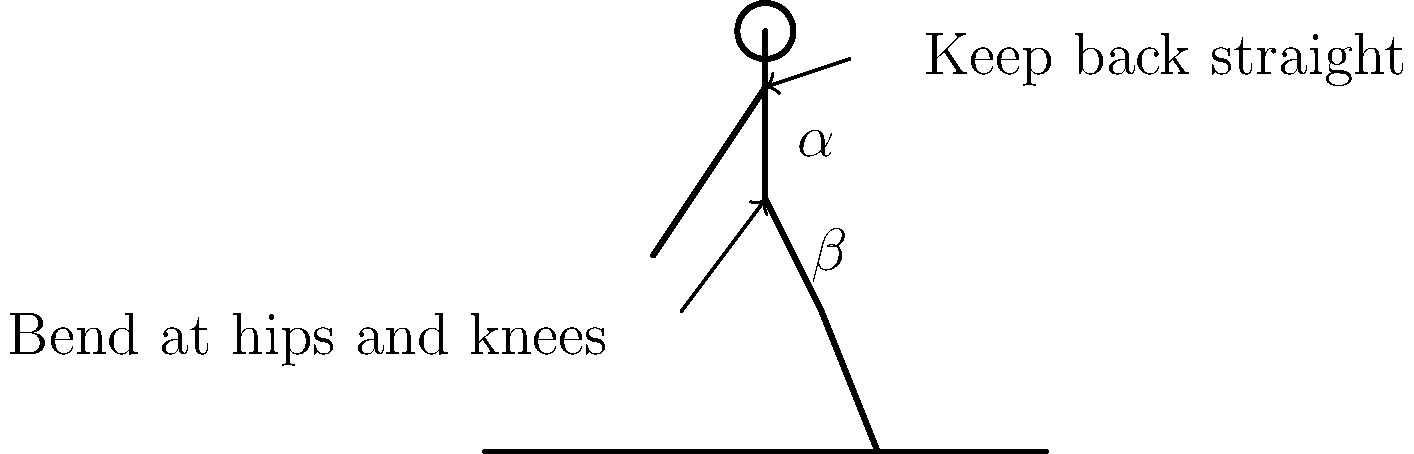When bending to plant seeds in a field, which of the following practices is most important for maintaining proper biomechanics and reducing the risk of back injury?

A) Bending primarily at the waist
B) Keeping the back straight and bending at the hips and knees
C) Twisting the upper body while bending
D) Reaching as far as possible to plant seeds To understand the correct biomechanics for bending to plant seeds, let's break down the proper technique:

1. Posture: The most crucial aspect is maintaining a straight back. This helps distribute the load evenly across the spine, reducing the risk of injury.

2. Bending points: Instead of bending primarily at the waist (which puts excessive strain on the lower back), the proper technique involves:
   a) Bending at the hips (hip flexion, angle $\alpha$ in the diagram)
   b) Bending at the knees (knee flexion, angle $\beta$ in the diagram)

3. Weight distribution: By bending at both the hips and knees, the body's weight is more evenly distributed, reducing the strain on any single joint or muscle group.

4. Stability: This position also provides a more stable base, reducing the risk of losing balance.

5. Avoid twisting: Keeping the shoulders and hips aligned (not twisting) while bending helps prevent torsional stress on the spine.

6. Proximity: Work close to the body rather than overreaching, which can cause imbalance and increased strain.

By following these principles, a farmer can significantly reduce the risk of back injury and other musculoskeletal problems associated with repetitive bending tasks in the field.
Answer: Keeping the back straight and bending at the hips and knees 